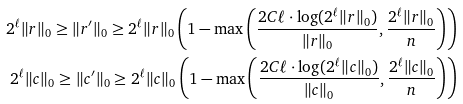Convert formula to latex. <formula><loc_0><loc_0><loc_500><loc_500>2 ^ { \ell } \| r \| _ { 0 } \geq \| r ^ { \prime } \| _ { 0 } \geq 2 ^ { \ell } \| r \| _ { 0 } \left ( 1 - \max \left ( \frac { 2 C \ell \cdot \log ( 2 ^ { \ell } \| r \| _ { 0 } ) } { \| r \| _ { 0 } } , \frac { 2 ^ { \ell } \| r \| _ { 0 } } { n } \right ) \right ) \\ 2 ^ { \ell } \| c \| _ { 0 } \geq \| c ^ { \prime } \| _ { 0 } \geq 2 ^ { \ell } \| c \| _ { 0 } \left ( 1 - \max \left ( \frac { 2 C \ell \cdot \log ( 2 ^ { \ell } \| c \| _ { 0 } ) } { \| c \| _ { 0 } } , \frac { 2 ^ { \ell } \| c \| _ { 0 } } { n } \right ) \right )</formula> 